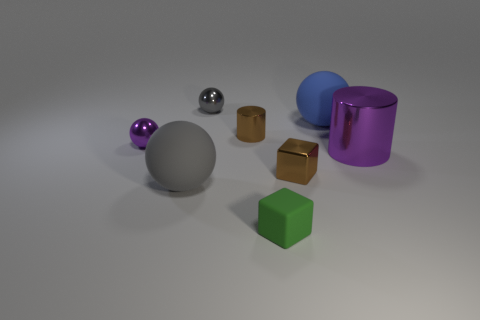The purple shiny object that is the same size as the blue rubber sphere is what shape? The purple object, which appears to have the same volume as the blue sphere, possesses a cylindrical shape. Its reflective surface suggests that it is possibly made of a metallic material, providing an interesting visual contrast to the matte texture of the spheres. 